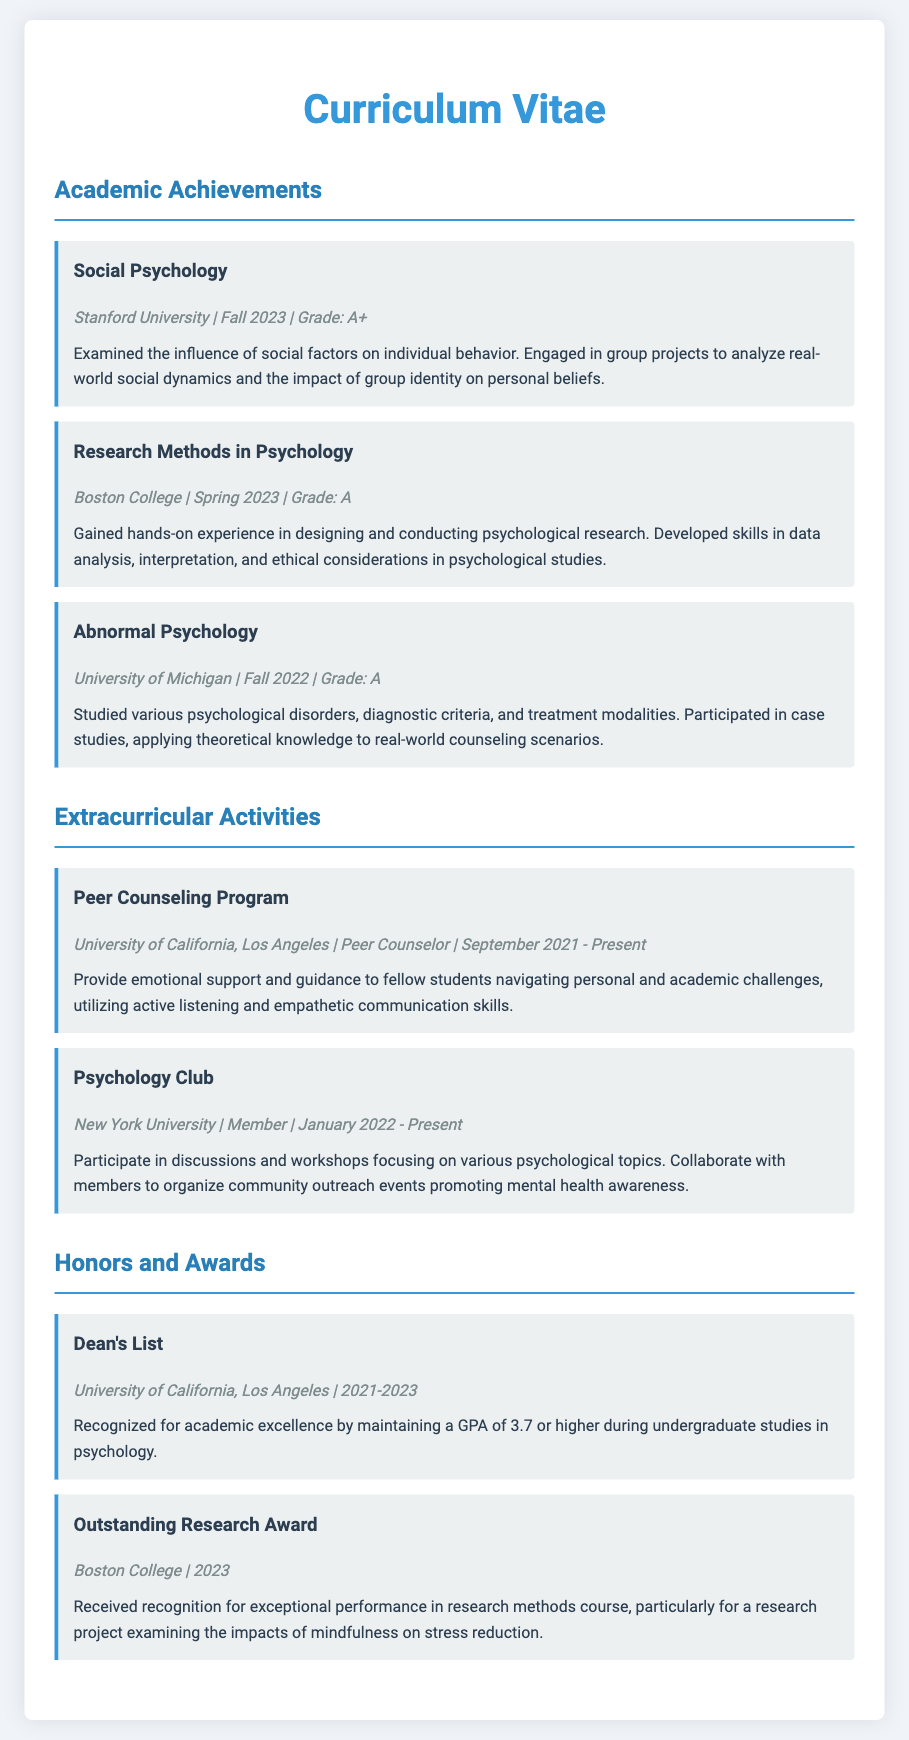what is the grade for Social Psychology? The grade for Social Psychology is A+.
Answer: A+ which university offered the Research Methods in Psychology course? The course was offered at Boston College.
Answer: Boston College in which semester did the student take Abnormal Psychology? The student took Abnormal Psychology in Fall 2022.
Answer: Fall 2022 how many years has the student been part of the Peer Counseling Program? The student has been part of the Peer Counseling Program since September 2021, which is approximately 2 years.
Answer: 2 years what award did the student receive for their research project in 2023? The student received the Outstanding Research Award for their project.
Answer: Outstanding Research Award which psychological topic did the student engage with in their Social Psychology course? The student examined the influence of social factors on individual behavior.
Answer: social factors how many courses listed received an A grade or higher? There are three courses listed that received an A grade or higher.
Answer: three what is the GPA threshold for being recognized on the Dean's List? The GPA threshold is 3.7 or higher.
Answer: 3.7 what is the focus of the Psychology Club activities? The focus is on discussing and promoting mental health awareness.
Answer: mental health awareness 